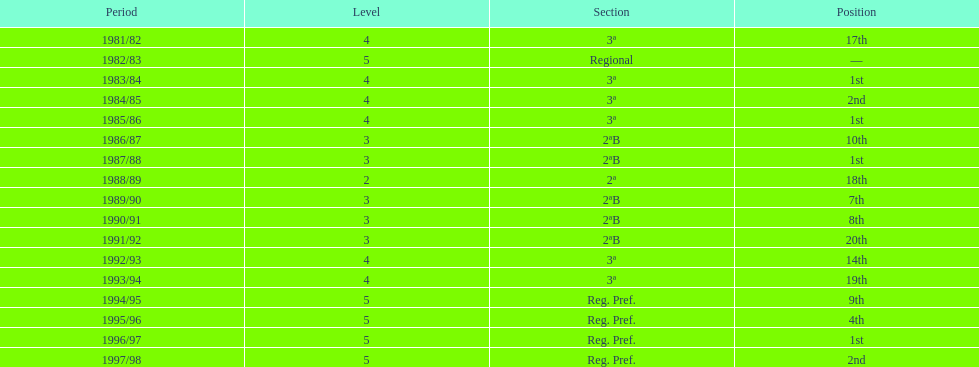When is the last year that the team has been division 2? 1991/92. 